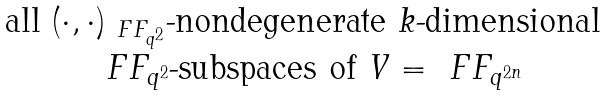Convert formula to latex. <formula><loc_0><loc_0><loc_500><loc_500>\begin{matrix} \text { all } ( \cdot , \cdot ) _ { \ F F _ { q ^ { 2 } } } \text {-nondegenerate } k \text {-dimensional } \ \\ \ F F _ { q ^ { 2 } } \text {-subspaces of } V = \ F F _ { q ^ { 2 n } } \end{matrix}</formula> 